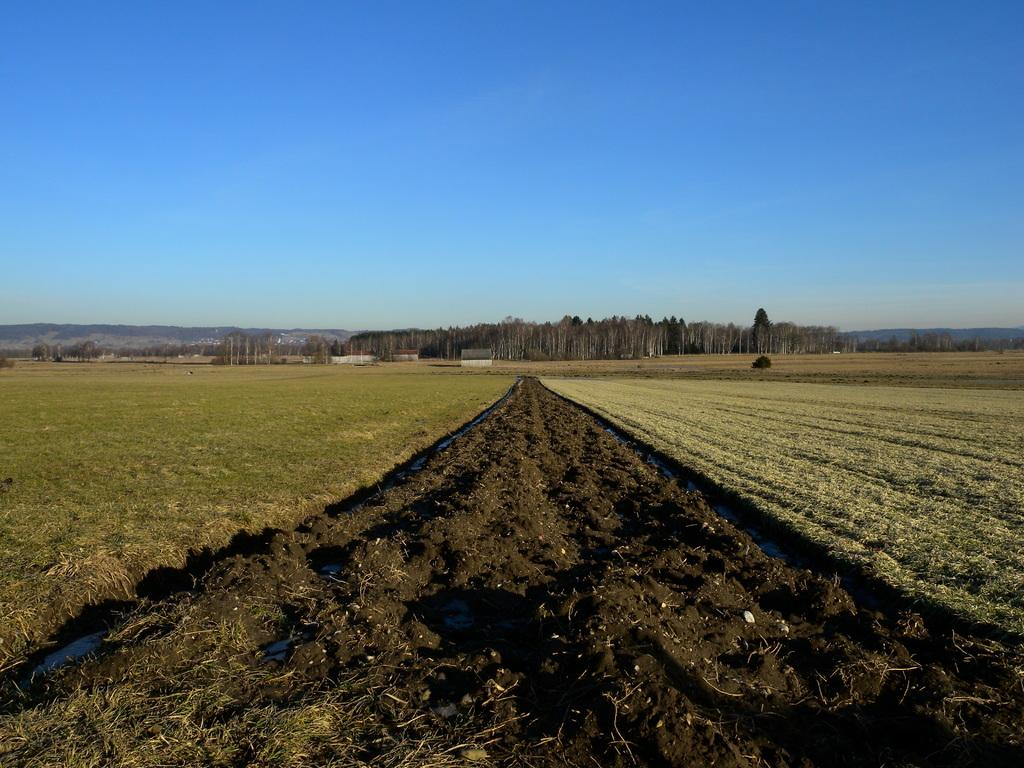What type of natural elements can be seen in the image? There is soil and water in the image. What is present on the ground on either side of the soil and water? There is greenery on the ground on either side of the soil and water. What can be seen in the background of the image? There are trees in the background of the image. What type of detail can be seen on the brother's shirt in the image? There is no brother or shirt present in the image. 